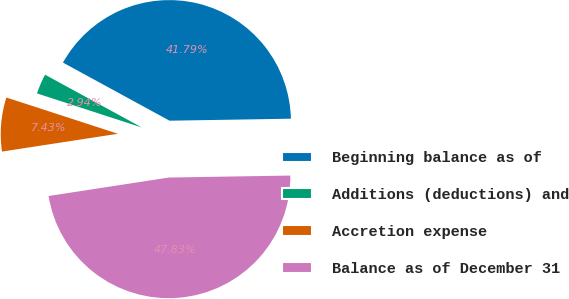Convert chart. <chart><loc_0><loc_0><loc_500><loc_500><pie_chart><fcel>Beginning balance as of<fcel>Additions (deductions) and<fcel>Accretion expense<fcel>Balance as of December 31<nl><fcel>41.79%<fcel>2.94%<fcel>7.43%<fcel>47.83%<nl></chart> 